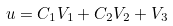Convert formula to latex. <formula><loc_0><loc_0><loc_500><loc_500>u = C _ { 1 } V _ { 1 } + C _ { 2 } V _ { 2 } + V _ { 3 }</formula> 